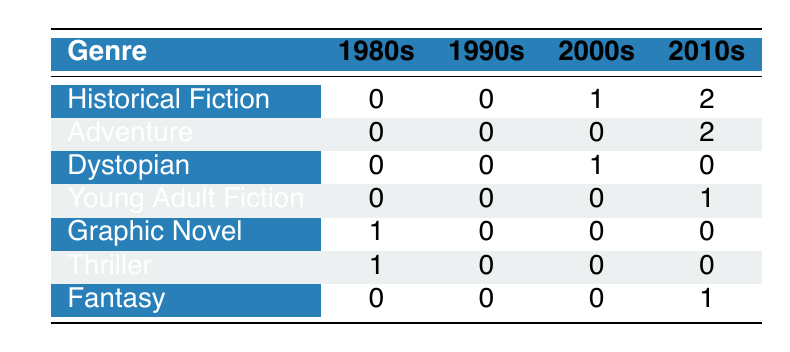What is the total number of Historical Fiction titles published in the 2000s? According to the table, there is 1 Historical Fiction title published in the 2000s. Therefore, the total is 1.
Answer: 1 How many genres have titles published in the 2010s? The genres represented in the 2010s include Historical Fiction (2 titles), Adventure (2 titles), Young Adult Fiction (1 title), and Fantasy (1 title). This combines to a total of 4 different genres.
Answer: 4 Is there any Dystopian title published in the 2010s? The table shows 0 Dystopian titles published in the 2010s. Therefore, the answer is no.
Answer: No What is the difference in the number of Graphic Novel titles published in the 1980s compared to the 2000s? There is 1 Graphic Novel title published in the 1980s and 0 in the 2000s. The difference is 1 - 0 = 1.
Answer: 1 Which genre has the highest number of titles published in the 2010s? There are 2 Historical Fiction titles and 2 Adventure titles in the 2010s, which is the highest count compared to other genres. Both genres share the highest number.
Answer: Historical Fiction and Adventure How many total titles are there from the 2000s? The 2000s have 1 Historical Fiction title, 1 Dystopian title, and 0 titles from other genres (Adventure, Young Adult Fiction, Graphic Novel, Thriller, Fantasy). Adding these gives a total of 2 titles.
Answer: 2 Does any genre have titles published in all four decades? By reviewing the table, no genre has titles published in the 1980s, 1990s, 2000s, and 2010s; all genres appear only in specific decades. Therefore, the answer is no.
Answer: No What percentage of the titles in the 2010s are Historical Fiction? There are a total of 6 titles in the 2010s (2 Historical Fiction, 2 Adventure, 1 Young Adult Fiction, and 1 Fantasy). The percentage of Historical Fiction titles is (2/6)*100, which equals approximately 33.33%.
Answer: 33.33% 